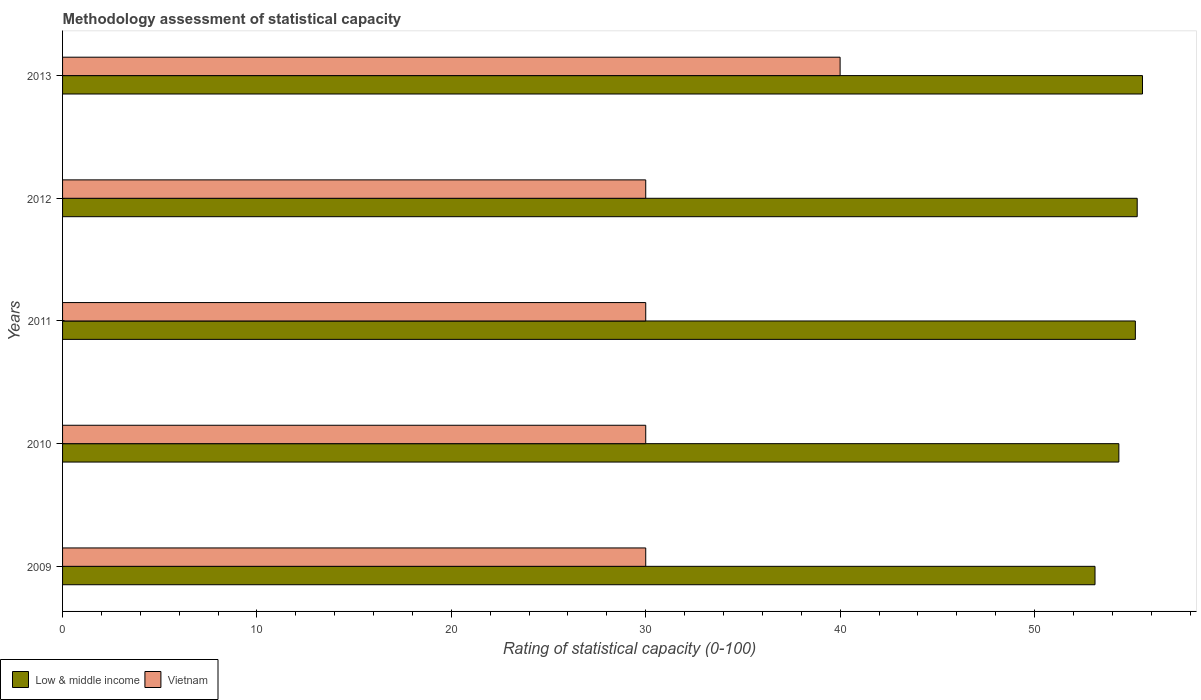How many different coloured bars are there?
Your answer should be compact. 2. How many groups of bars are there?
Your answer should be very brief. 5. Are the number of bars on each tick of the Y-axis equal?
Your answer should be compact. Yes. How many bars are there on the 5th tick from the top?
Offer a very short reply. 2. What is the label of the 1st group of bars from the top?
Offer a very short reply. 2013. In how many cases, is the number of bars for a given year not equal to the number of legend labels?
Ensure brevity in your answer.  0. What is the rating of statistical capacity in Vietnam in 2011?
Ensure brevity in your answer.  30. Across all years, what is the maximum rating of statistical capacity in Vietnam?
Make the answer very short. 40. Across all years, what is the minimum rating of statistical capacity in Vietnam?
Provide a short and direct response. 30. In which year was the rating of statistical capacity in Low & middle income maximum?
Your answer should be very brief. 2013. In which year was the rating of statistical capacity in Low & middle income minimum?
Keep it short and to the point. 2009. What is the total rating of statistical capacity in Vietnam in the graph?
Make the answer very short. 160. What is the difference between the rating of statistical capacity in Low & middle income in 2012 and that in 2013?
Ensure brevity in your answer.  -0.27. What is the difference between the rating of statistical capacity in Low & middle income in 2009 and the rating of statistical capacity in Vietnam in 2012?
Your answer should be compact. 23.11. What is the average rating of statistical capacity in Vietnam per year?
Give a very brief answer. 32. In the year 2009, what is the difference between the rating of statistical capacity in Vietnam and rating of statistical capacity in Low & middle income?
Ensure brevity in your answer.  -23.11. In how many years, is the rating of statistical capacity in Low & middle income greater than 40 ?
Give a very brief answer. 5. What is the ratio of the rating of statistical capacity in Vietnam in 2009 to that in 2012?
Ensure brevity in your answer.  1. What is the difference between the highest and the second highest rating of statistical capacity in Low & middle income?
Provide a succinct answer. 0.27. What is the difference between the highest and the lowest rating of statistical capacity in Low & middle income?
Provide a short and direct response. 2.44. What does the 1st bar from the top in 2011 represents?
Provide a short and direct response. Vietnam. What does the 1st bar from the bottom in 2013 represents?
Offer a very short reply. Low & middle income. How many bars are there?
Keep it short and to the point. 10. Are all the bars in the graph horizontal?
Keep it short and to the point. Yes. How many years are there in the graph?
Offer a terse response. 5. What is the difference between two consecutive major ticks on the X-axis?
Your answer should be compact. 10. Are the values on the major ticks of X-axis written in scientific E-notation?
Your answer should be very brief. No. Does the graph contain any zero values?
Your answer should be compact. No. Where does the legend appear in the graph?
Keep it short and to the point. Bottom left. What is the title of the graph?
Give a very brief answer. Methodology assessment of statistical capacity. Does "Netherlands" appear as one of the legend labels in the graph?
Your answer should be very brief. No. What is the label or title of the X-axis?
Give a very brief answer. Rating of statistical capacity (0-100). What is the label or title of the Y-axis?
Your answer should be very brief. Years. What is the Rating of statistical capacity (0-100) in Low & middle income in 2009?
Provide a succinct answer. 53.11. What is the Rating of statistical capacity (0-100) in Low & middle income in 2010?
Provide a short and direct response. 54.34. What is the Rating of statistical capacity (0-100) in Low & middle income in 2011?
Give a very brief answer. 55.19. What is the Rating of statistical capacity (0-100) of Vietnam in 2011?
Provide a succinct answer. 30. What is the Rating of statistical capacity (0-100) in Low & middle income in 2012?
Give a very brief answer. 55.28. What is the Rating of statistical capacity (0-100) of Low & middle income in 2013?
Your answer should be compact. 55.56. Across all years, what is the maximum Rating of statistical capacity (0-100) in Low & middle income?
Ensure brevity in your answer.  55.56. Across all years, what is the maximum Rating of statistical capacity (0-100) of Vietnam?
Give a very brief answer. 40. Across all years, what is the minimum Rating of statistical capacity (0-100) in Low & middle income?
Keep it short and to the point. 53.11. What is the total Rating of statistical capacity (0-100) of Low & middle income in the graph?
Your response must be concise. 273.48. What is the total Rating of statistical capacity (0-100) in Vietnam in the graph?
Make the answer very short. 160. What is the difference between the Rating of statistical capacity (0-100) in Low & middle income in 2009 and that in 2010?
Ensure brevity in your answer.  -1.23. What is the difference between the Rating of statistical capacity (0-100) in Low & middle income in 2009 and that in 2011?
Offer a terse response. -2.08. What is the difference between the Rating of statistical capacity (0-100) in Low & middle income in 2009 and that in 2012?
Offer a terse response. -2.17. What is the difference between the Rating of statistical capacity (0-100) in Low & middle income in 2009 and that in 2013?
Your answer should be very brief. -2.44. What is the difference between the Rating of statistical capacity (0-100) of Vietnam in 2009 and that in 2013?
Provide a short and direct response. -10. What is the difference between the Rating of statistical capacity (0-100) in Low & middle income in 2010 and that in 2011?
Provide a succinct answer. -0.85. What is the difference between the Rating of statistical capacity (0-100) in Vietnam in 2010 and that in 2011?
Provide a short and direct response. 0. What is the difference between the Rating of statistical capacity (0-100) in Low & middle income in 2010 and that in 2012?
Provide a succinct answer. -0.94. What is the difference between the Rating of statistical capacity (0-100) in Vietnam in 2010 and that in 2012?
Your answer should be very brief. 0. What is the difference between the Rating of statistical capacity (0-100) of Low & middle income in 2010 and that in 2013?
Make the answer very short. -1.22. What is the difference between the Rating of statistical capacity (0-100) in Low & middle income in 2011 and that in 2012?
Make the answer very short. -0.09. What is the difference between the Rating of statistical capacity (0-100) in Vietnam in 2011 and that in 2012?
Offer a very short reply. 0. What is the difference between the Rating of statistical capacity (0-100) of Low & middle income in 2011 and that in 2013?
Your response must be concise. -0.37. What is the difference between the Rating of statistical capacity (0-100) in Low & middle income in 2012 and that in 2013?
Offer a terse response. -0.27. What is the difference between the Rating of statistical capacity (0-100) of Vietnam in 2012 and that in 2013?
Offer a terse response. -10. What is the difference between the Rating of statistical capacity (0-100) of Low & middle income in 2009 and the Rating of statistical capacity (0-100) of Vietnam in 2010?
Offer a very short reply. 23.11. What is the difference between the Rating of statistical capacity (0-100) of Low & middle income in 2009 and the Rating of statistical capacity (0-100) of Vietnam in 2011?
Provide a succinct answer. 23.11. What is the difference between the Rating of statistical capacity (0-100) of Low & middle income in 2009 and the Rating of statistical capacity (0-100) of Vietnam in 2012?
Offer a very short reply. 23.11. What is the difference between the Rating of statistical capacity (0-100) in Low & middle income in 2009 and the Rating of statistical capacity (0-100) in Vietnam in 2013?
Provide a short and direct response. 13.11. What is the difference between the Rating of statistical capacity (0-100) of Low & middle income in 2010 and the Rating of statistical capacity (0-100) of Vietnam in 2011?
Provide a short and direct response. 24.34. What is the difference between the Rating of statistical capacity (0-100) in Low & middle income in 2010 and the Rating of statistical capacity (0-100) in Vietnam in 2012?
Provide a succinct answer. 24.34. What is the difference between the Rating of statistical capacity (0-100) of Low & middle income in 2010 and the Rating of statistical capacity (0-100) of Vietnam in 2013?
Provide a succinct answer. 14.34. What is the difference between the Rating of statistical capacity (0-100) of Low & middle income in 2011 and the Rating of statistical capacity (0-100) of Vietnam in 2012?
Keep it short and to the point. 25.19. What is the difference between the Rating of statistical capacity (0-100) in Low & middle income in 2011 and the Rating of statistical capacity (0-100) in Vietnam in 2013?
Make the answer very short. 15.19. What is the difference between the Rating of statistical capacity (0-100) of Low & middle income in 2012 and the Rating of statistical capacity (0-100) of Vietnam in 2013?
Your answer should be compact. 15.28. What is the average Rating of statistical capacity (0-100) in Low & middle income per year?
Give a very brief answer. 54.7. In the year 2009, what is the difference between the Rating of statistical capacity (0-100) in Low & middle income and Rating of statistical capacity (0-100) in Vietnam?
Offer a very short reply. 23.11. In the year 2010, what is the difference between the Rating of statistical capacity (0-100) in Low & middle income and Rating of statistical capacity (0-100) in Vietnam?
Ensure brevity in your answer.  24.34. In the year 2011, what is the difference between the Rating of statistical capacity (0-100) of Low & middle income and Rating of statistical capacity (0-100) of Vietnam?
Keep it short and to the point. 25.19. In the year 2012, what is the difference between the Rating of statistical capacity (0-100) in Low & middle income and Rating of statistical capacity (0-100) in Vietnam?
Ensure brevity in your answer.  25.28. In the year 2013, what is the difference between the Rating of statistical capacity (0-100) of Low & middle income and Rating of statistical capacity (0-100) of Vietnam?
Keep it short and to the point. 15.56. What is the ratio of the Rating of statistical capacity (0-100) in Low & middle income in 2009 to that in 2010?
Provide a short and direct response. 0.98. What is the ratio of the Rating of statistical capacity (0-100) of Vietnam in 2009 to that in 2010?
Provide a short and direct response. 1. What is the ratio of the Rating of statistical capacity (0-100) in Low & middle income in 2009 to that in 2011?
Offer a terse response. 0.96. What is the ratio of the Rating of statistical capacity (0-100) of Low & middle income in 2009 to that in 2012?
Your answer should be compact. 0.96. What is the ratio of the Rating of statistical capacity (0-100) in Low & middle income in 2009 to that in 2013?
Provide a short and direct response. 0.96. What is the ratio of the Rating of statistical capacity (0-100) in Vietnam in 2009 to that in 2013?
Your response must be concise. 0.75. What is the ratio of the Rating of statistical capacity (0-100) of Low & middle income in 2010 to that in 2011?
Give a very brief answer. 0.98. What is the ratio of the Rating of statistical capacity (0-100) in Low & middle income in 2010 to that in 2012?
Make the answer very short. 0.98. What is the ratio of the Rating of statistical capacity (0-100) of Low & middle income in 2010 to that in 2013?
Ensure brevity in your answer.  0.98. What is the ratio of the Rating of statistical capacity (0-100) of Low & middle income in 2011 to that in 2012?
Make the answer very short. 1. What is the ratio of the Rating of statistical capacity (0-100) of Low & middle income in 2011 to that in 2013?
Keep it short and to the point. 0.99. What is the ratio of the Rating of statistical capacity (0-100) of Vietnam in 2011 to that in 2013?
Provide a short and direct response. 0.75. What is the difference between the highest and the second highest Rating of statistical capacity (0-100) in Low & middle income?
Your answer should be very brief. 0.27. What is the difference between the highest and the lowest Rating of statistical capacity (0-100) in Low & middle income?
Ensure brevity in your answer.  2.44. 